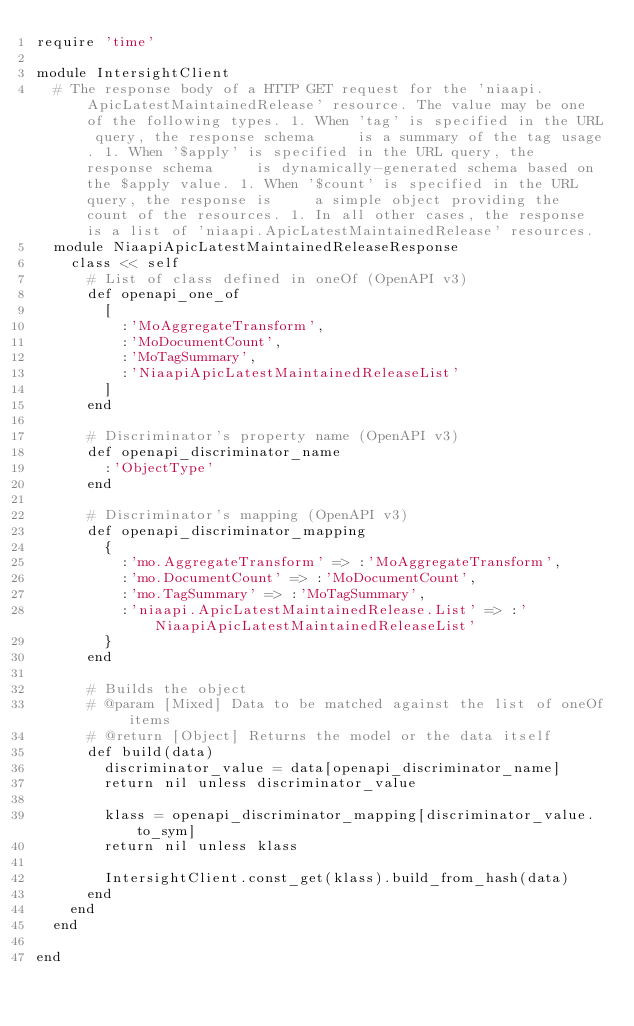Convert code to text. <code><loc_0><loc_0><loc_500><loc_500><_Ruby_>require 'time'

module IntersightClient
  # The response body of a HTTP GET request for the 'niaapi.ApicLatestMaintainedRelease' resource. The value may be one of the following types. 1. When 'tag' is specified in the URL query, the response schema     is a summary of the tag usage. 1. When '$apply' is specified in the URL query, the response schema     is dynamically-generated schema based on the $apply value. 1. When '$count' is specified in the URL query, the response is     a simple object providing the count of the resources. 1. In all other cases, the response is a list of 'niaapi.ApicLatestMaintainedRelease' resources.
  module NiaapiApicLatestMaintainedReleaseResponse
    class << self
      # List of class defined in oneOf (OpenAPI v3)
      def openapi_one_of
        [
          :'MoAggregateTransform',
          :'MoDocumentCount',
          :'MoTagSummary',
          :'NiaapiApicLatestMaintainedReleaseList'
        ]
      end

      # Discriminator's property name (OpenAPI v3)
      def openapi_discriminator_name
        :'ObjectType'
      end

      # Discriminator's mapping (OpenAPI v3)
      def openapi_discriminator_mapping
        {
          :'mo.AggregateTransform' => :'MoAggregateTransform',
          :'mo.DocumentCount' => :'MoDocumentCount',
          :'mo.TagSummary' => :'MoTagSummary',
          :'niaapi.ApicLatestMaintainedRelease.List' => :'NiaapiApicLatestMaintainedReleaseList'
        }
      end

      # Builds the object
      # @param [Mixed] Data to be matched against the list of oneOf items
      # @return [Object] Returns the model or the data itself
      def build(data)
        discriminator_value = data[openapi_discriminator_name]
        return nil unless discriminator_value

        klass = openapi_discriminator_mapping[discriminator_value.to_sym]
        return nil unless klass

        IntersightClient.const_get(klass).build_from_hash(data)
      end
    end
  end

end
</code> 